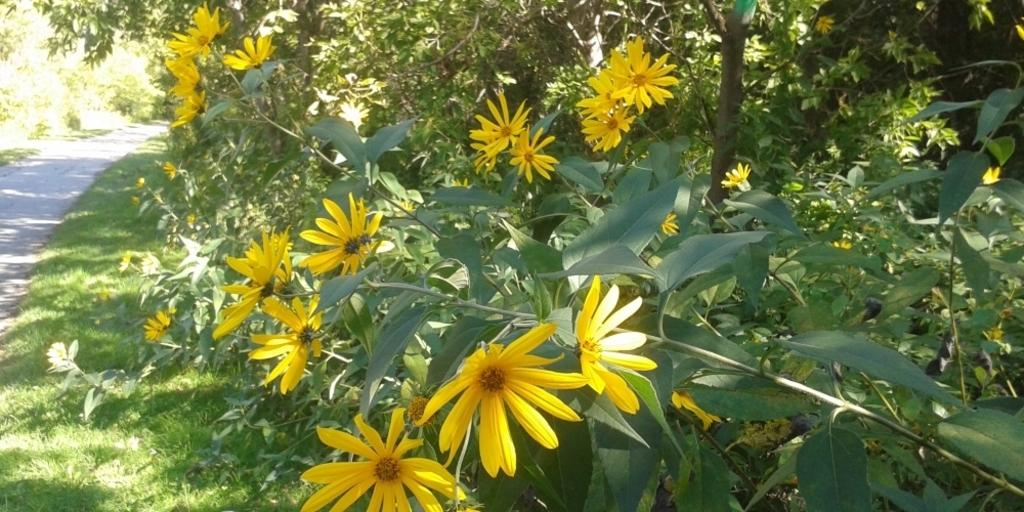What is the main subject in the center of the image? There are flower plants in the center of the image. What can be seen in the background of the image? There are trees in the background of the image. What is located to the left side of the image? There is a road to the left side of the image. What type of vegetation is visible in the image? There is grass visible in the image. What type of hammer is being used to water the flower plants in the image? There is no hammer present in the image; the flower plants are not being watered. 